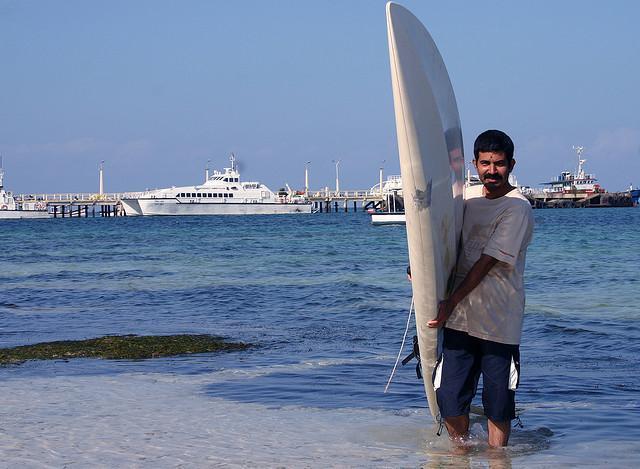How many surfboards are there?
Give a very brief answer. 1. How many surfboards are pictured?
Give a very brief answer. 1. How many surfboard?
Give a very brief answer. 1. How many boats can you see?
Give a very brief answer. 2. How many pizzas are pictured?
Give a very brief answer. 0. 